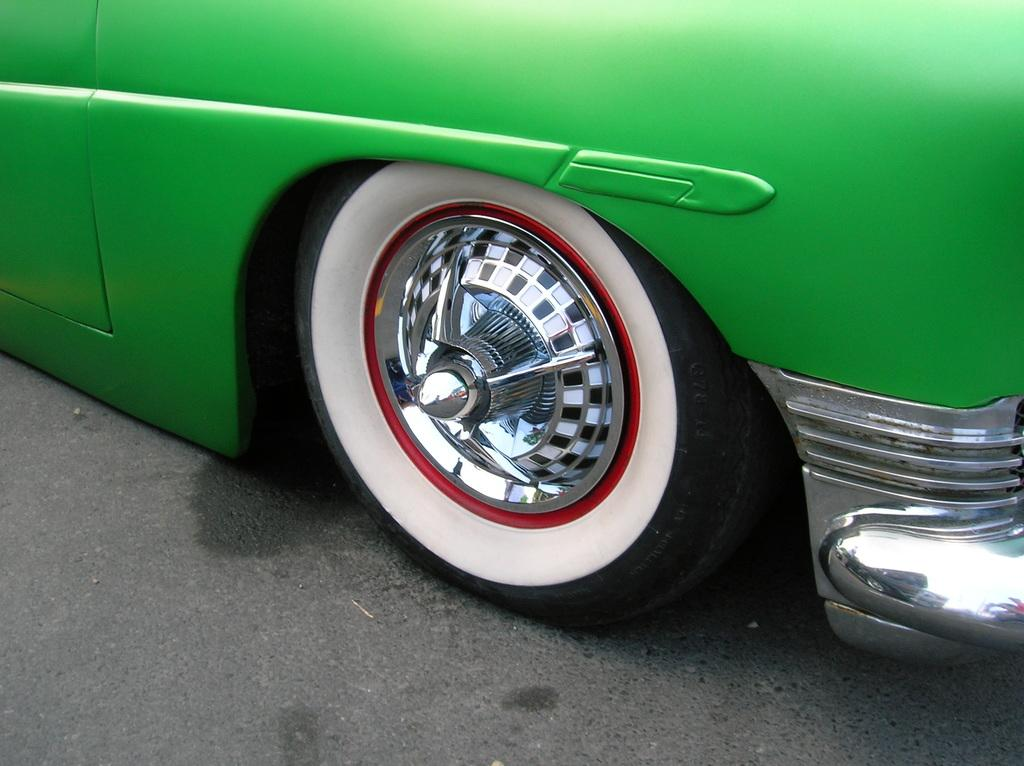What color is the vehicle in the image? The vehicle in the image is green. What part of the vehicle can be seen in the image? There is a tire visible in the image. What type of surface is visible at the bottom of the image? The road is visible at the bottom of the image. What is the rate of dust accumulation on the vehicle in the image? There is no information about dust accumulation on the vehicle in the image, so it cannot be determined. 